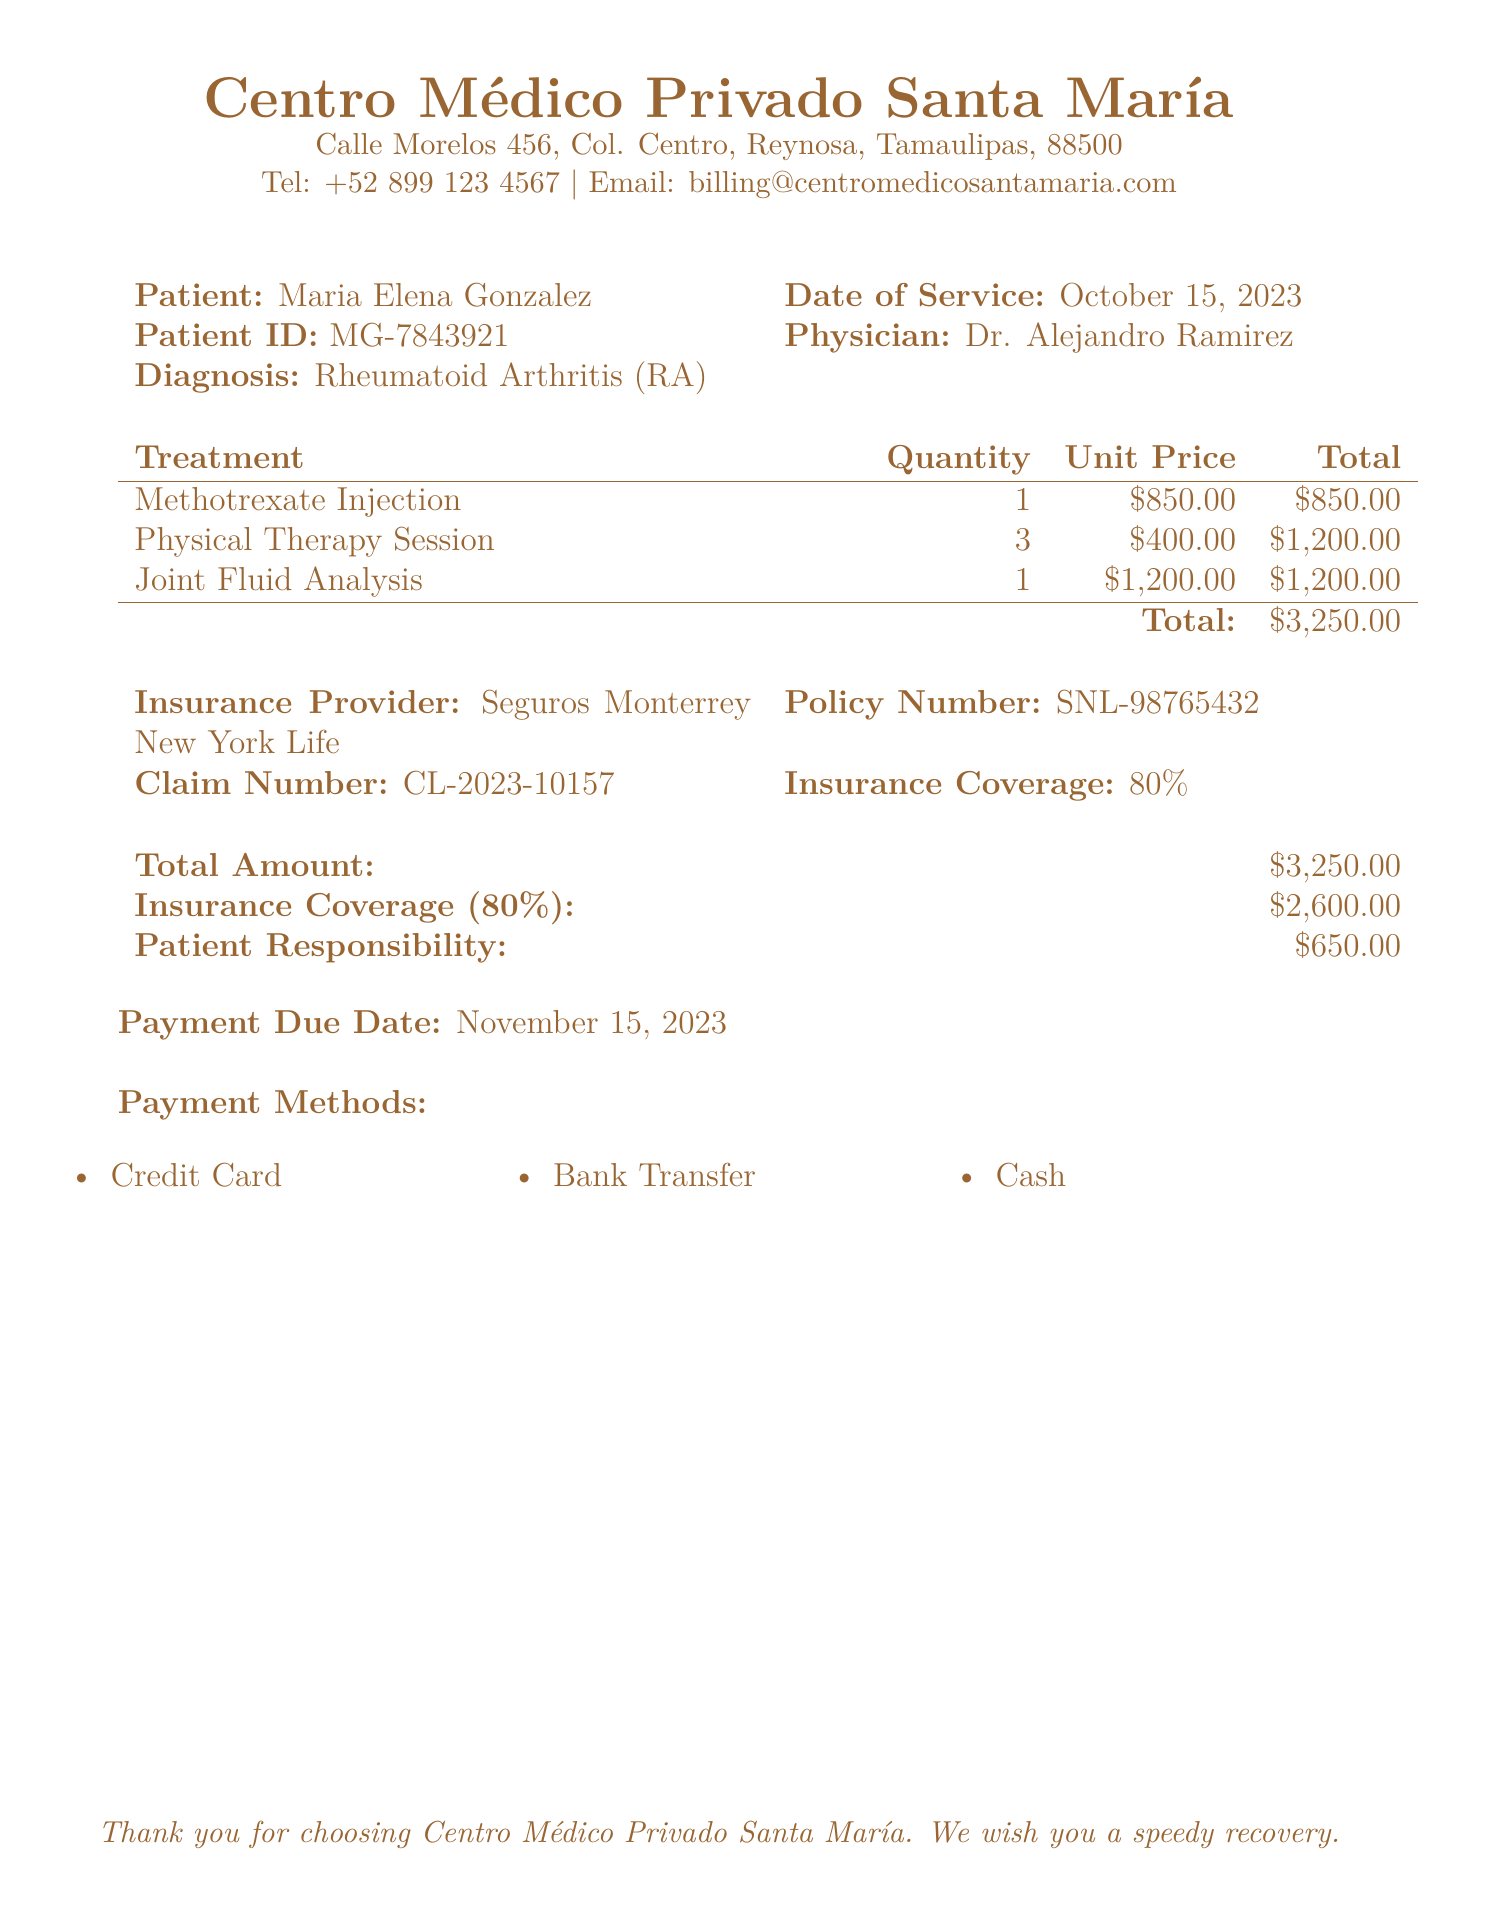What is the patient's name? The patient's name is listed at the top of the bill.
Answer: Maria Elena Gonzalez What is the date of service? The date of service is mentioned in the document.
Answer: October 15, 2023 What is the total amount billed? The total amount billed is mentioned in the billing section of the document.
Answer: $3,250.00 What percentage of coverage does the insurance provide? The insurance coverage percentage is indicated in the insurance section.
Answer: 80% How much is the patient responsible to pay? The patient's responsibility is clearly stated in the billing section.
Answer: $650.00 What is the claim number? The claim number is provided under the insurance information.
Answer: CL-2023-10157 How many physical therapy sessions were billed? The quantity of physical therapy sessions is listed in the treatment table.
Answer: 3 What is the unit price for the Methotrexate injection? The unit price for Methotrexate injection can be found in the treatment table.
Answer: $850.00 When is the payment due date? The payment due date is specified at the end of the document.
Answer: November 15, 2023 